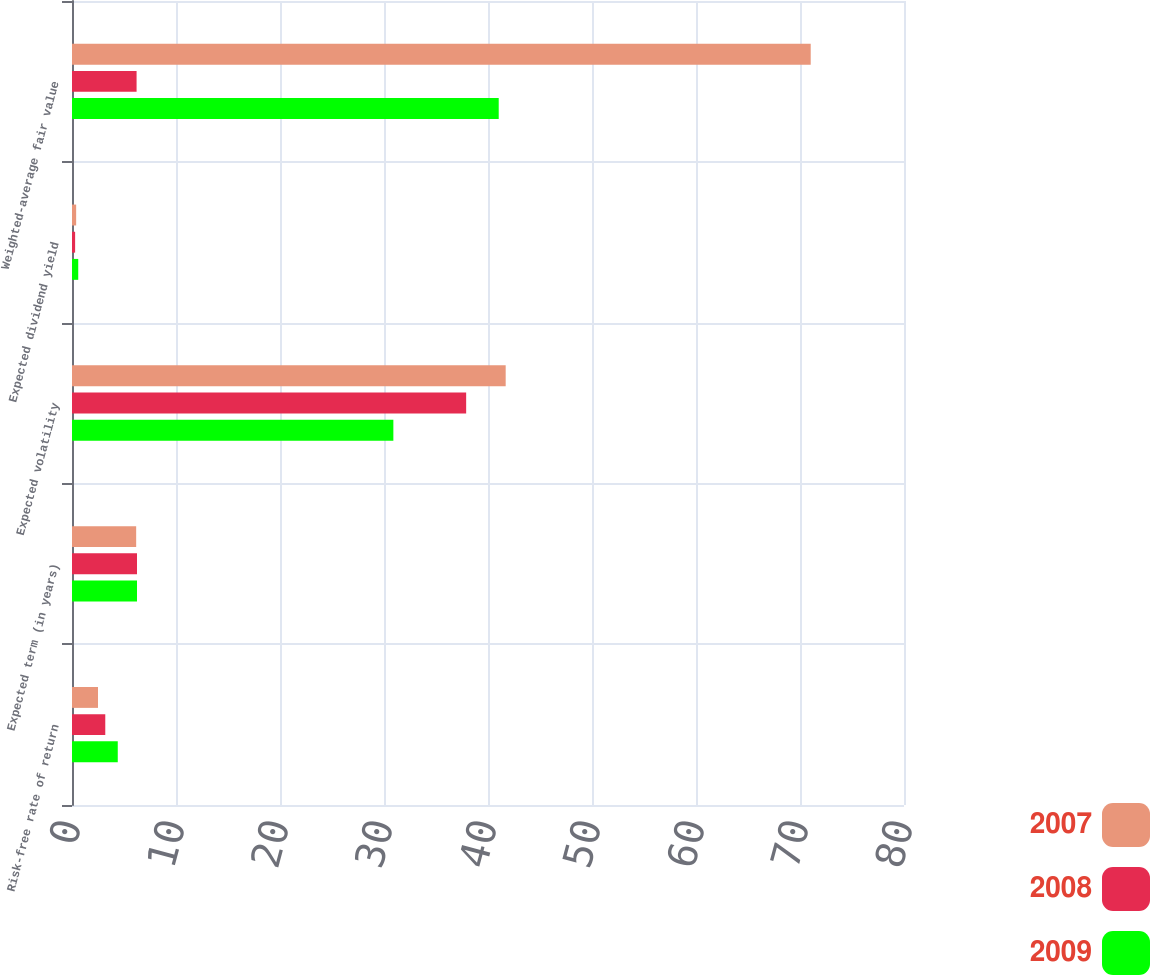<chart> <loc_0><loc_0><loc_500><loc_500><stacked_bar_chart><ecel><fcel>Risk-free rate of return<fcel>Expected term (in years)<fcel>Expected volatility<fcel>Expected dividend yield<fcel>Weighted-average fair value<nl><fcel>2007<fcel>2.5<fcel>6.17<fcel>41.7<fcel>0.4<fcel>71.03<nl><fcel>2008<fcel>3.2<fcel>6.25<fcel>37.9<fcel>0.3<fcel>6.21<nl><fcel>2009<fcel>4.4<fcel>6.25<fcel>30.9<fcel>0.6<fcel>41.03<nl></chart> 